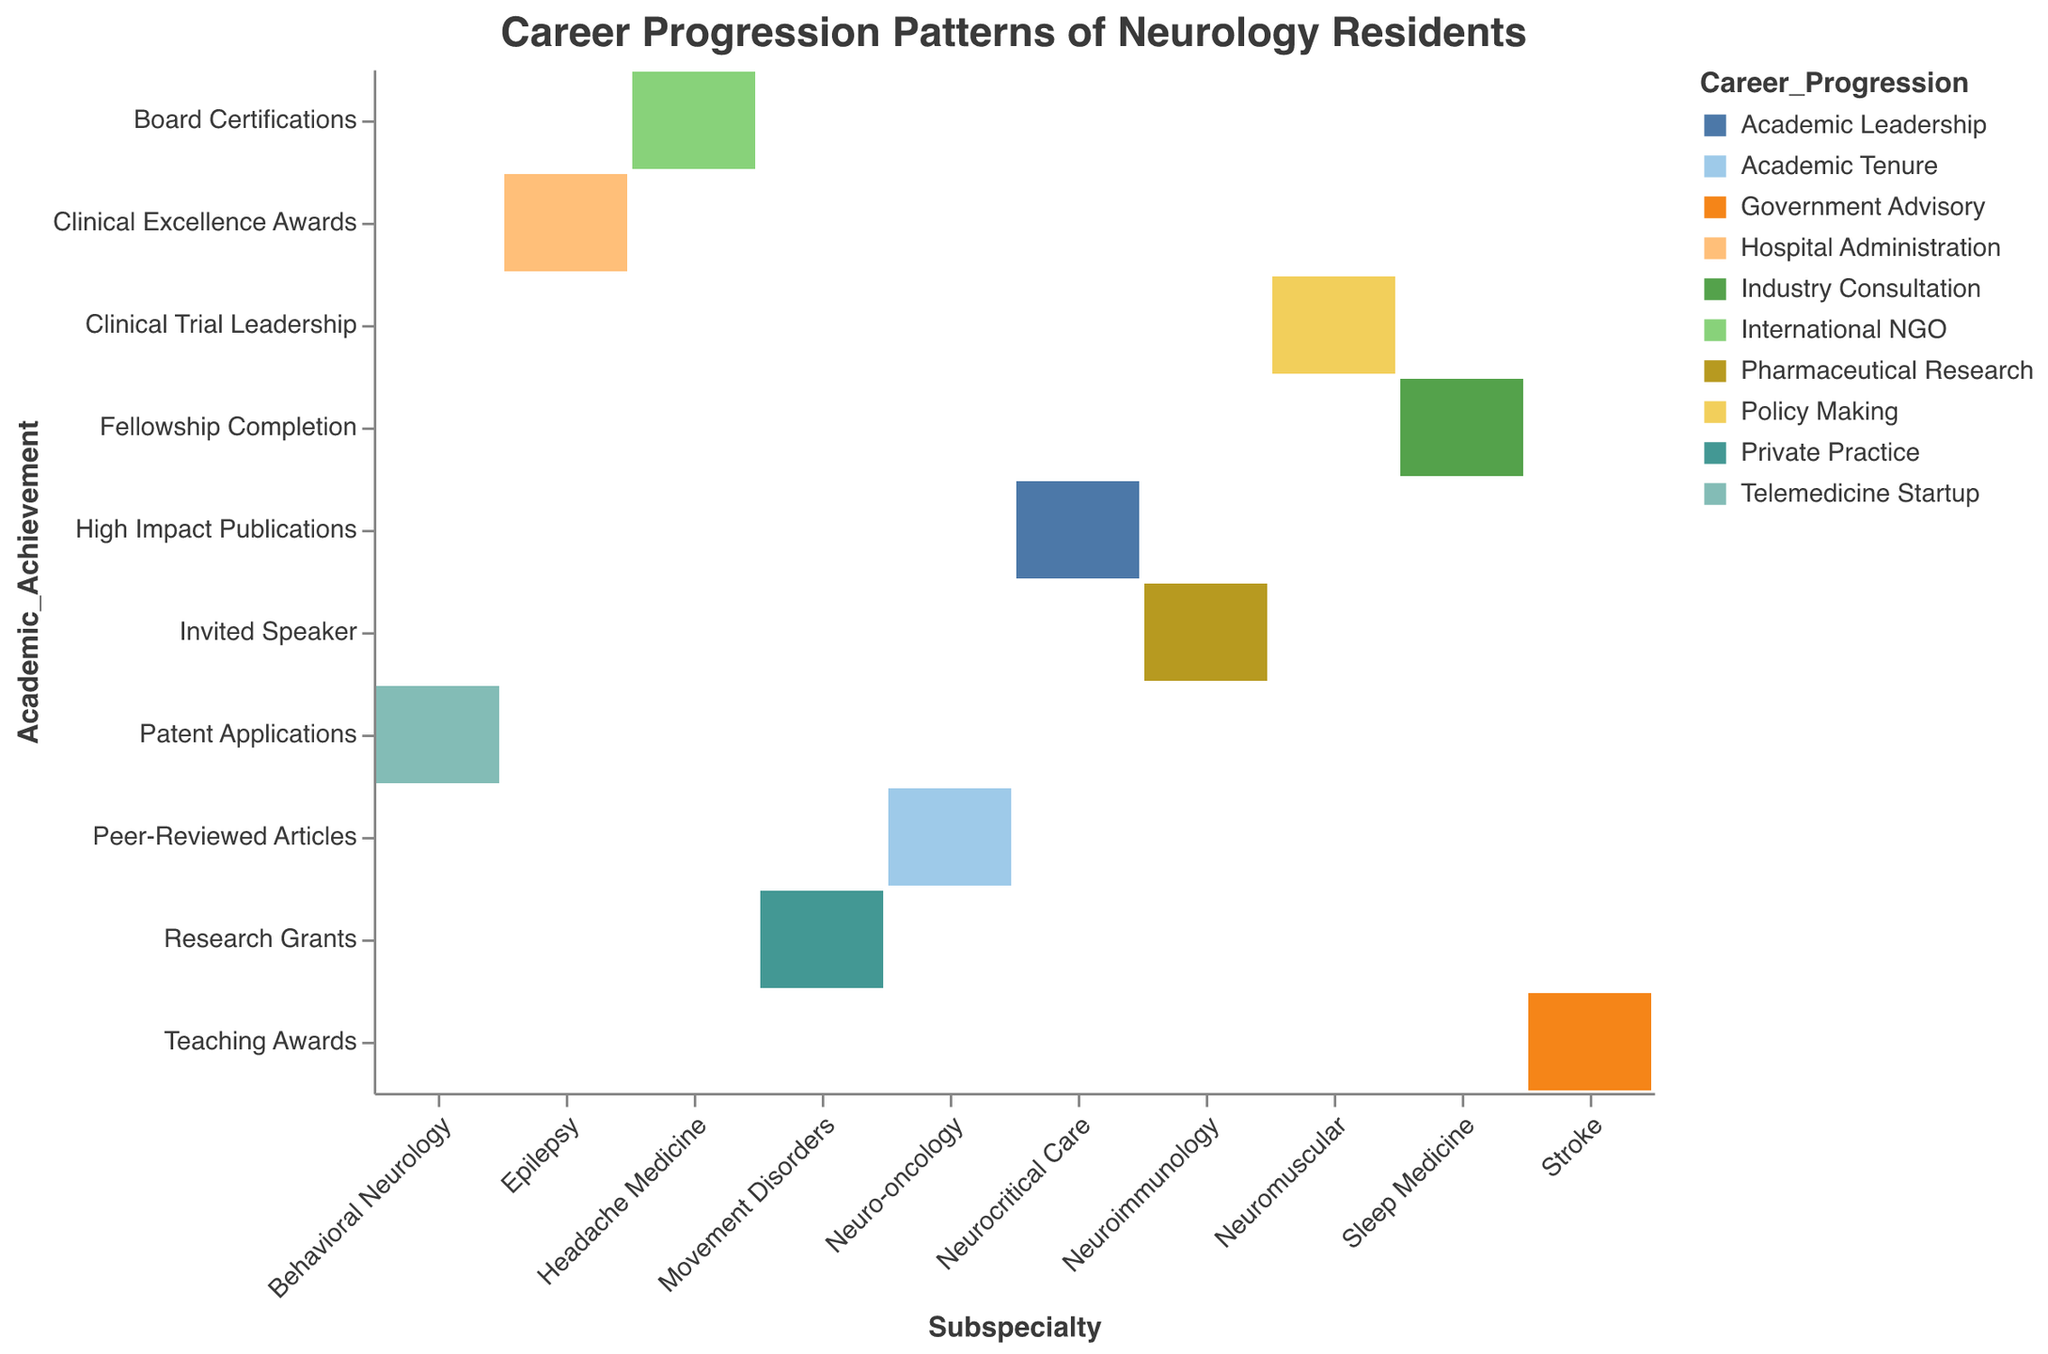What is the title of the figure? The title is usually placed at the top of the figure and indicates the main purpose or focus of the visualization.
Answer: Career Progression Patterns of Neurology Residents How many different subspecialties are represented in the figure? The subspecialties are indicated along the x-axis of the mosaic plot. By counting the unique labels on the x-axis, we can determine the number of different subspecialties.
Answer: 10 What academic achievement is associated with Epilepsy? To determine the academic achievement associated with Epilepsy, look for the block corresponding to Epilepsy on the x-axis and identify the associated label on the y-axis.
Answer: Clinical Excellence Awards Which subspecialty leads to a career progression in Government Advisory? By examining the color legend and finding the block that matches the color associated with Government Advisory, we can trace it back to the corresponding subspecialty on the x-axis.
Answer: Stroke Which subspecialty has the most diverse career progression paths? To answer this, we need to observe the number of different colors (representing career progression paths) present within each subspecialty's block on the x-axis. The subspecialty with the highest diversity will have the most distinct colors.
Answer: Neuro-oncology How many subspecialties are associated with Academic Leadership as a career progression? By finding the segment in the figure that corresponds to Academic Leadership in the legend and counting the number of blocks matching that color, we can determine the number of associated subspecialties.
Answer: 1 What is the relationship between Board Certifications and career progression in International NGO? First, identify the academic achievement Board Certifications on the y-axis, then trace horizontally to find the block with the same color as International NGO in the figure legend.
Answer: Headache Medicine Which subspecialty corresponds to the least common academic achievement? Observe the frequency of each academic achievement label on the y-axis and identify the one with the fewest occurrences. Then determine which subspecialty this academic achievement corresponds to.
Answer: Behavioral Neurology (Patent Applications) Between Neuroimmunology and Neuro-oncology, which has a higher likelihood to transition into Pharmaceutical Research? Identify the segments for both Neuroimmunology and Neuro-oncology and then see which has the color corresponding to Pharmaceutical Research as per the legend. Confirm this for each subspecialty.
Answer: Neuroimmunology 